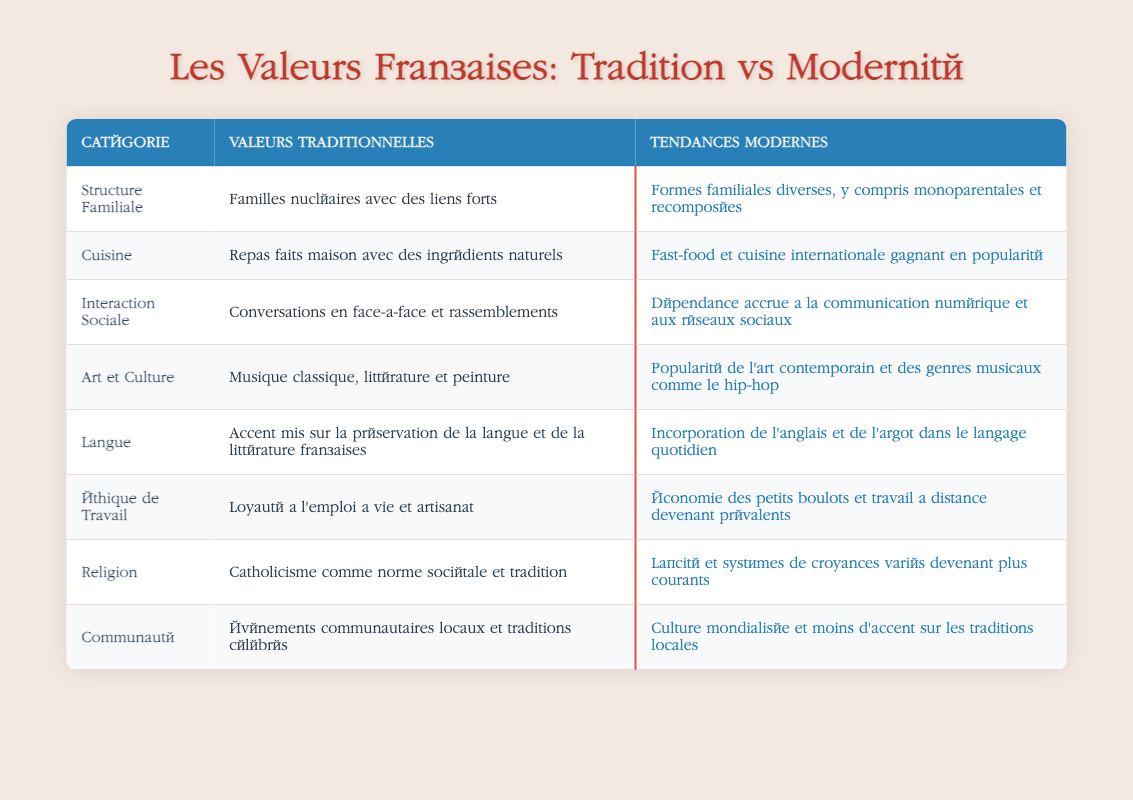What is the traditional view of family structure in France? The traditional view of family structure in France, as indicated in the table, is "Nuclear families with strong ties." This can be found directly in the row corresponding to "Structure Familiale" under the column "Valeurs Traditionnelles."
Answer: Nuclear families with strong ties How does the modern view of cuisine differ from the traditional view? The modern view of cuisine is described as "Fast food and international cuisine gaining popularity," while the traditional view emphasizes "Homemade meals with natural ingredients." These contrasting descriptions are found in the row labeled "Cuisine."
Answer: Fast food and international cuisine gaining popularity Is it true that modern social interaction relies more on digital communication than traditional face-to-face conversations? Yes, it is true. The table states that modern social interaction involves "Increased reliance on digital communication and social media," while traditional social interaction is characterized by "Face-to-face conversations and gatherings." The differing views indicate a shift towards digital communication in modern times.
Answer: Yes What is the difference in work ethic between traditional and modern values? Traditional work ethic is "Lifelong employment loyalty and craftsmanship," whereas modern work ethic is characterized by "Gig economy and remote working becoming prevalent." To find the answer, look at the "Éthique de Travail" row where both descriptions are compared side by side.
Answer: Gig economy and remote working becoming prevalent Which category reflects a shift in community engagement from traditional to modern values? The category reflecting this shift is "Communauté." The traditional value emphasizes "Local community events and traditions celebrated," while the modern trend indicates "Globalized culture and less emphasis on local traditions." This demonstrates a move away from local engagement towards a more global perspective.
Answer: Globalized culture and less emphasis on local traditions How does the view on art and culture vary between the traditional and modern perspectives? The traditional view of art and culture emphasizes "Classical music, literature, and painting," while the modern view appreciates "Popularity of contemporary art and music genres such as hip-hop." This difference can be found under the "Art et Culture" row of the table, illustrating a distinct shift in cultural preferences.
Answer: Popularity of contemporary art and music genres such as hip-hop What is the traditional stance on religion in the table? The traditional stance on religion, as shown in the table, is "Catholicism as a societal norm and tradition." This is located in the row for "Religion" under the traditional values column.
Answer: Catholicism as a societal norm and tradition How would you summarize the change in language use from traditional values to modern trends? The traditional value emphasizes "Emphasis on preserving the French language and literature," while modern trends reflect "Incorporation of English and slang in everyday language." This summary is derived from the "Langue" row, which shows how language use has evolved over time in France.
Answer: Incorporation of English and slang in everyday language 